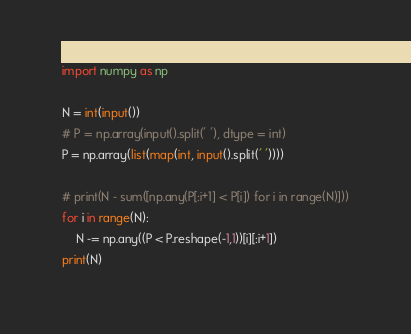<code> <loc_0><loc_0><loc_500><loc_500><_Python_>import numpy as np

N = int(input())
# P = np.array(input().split(' '), dtype = int)
P = np.array(list(map(int, input().split(' '))))

# print(N - sum([np.any(P[:i+1] < P[i]) for i in range(N)]))
for i in range(N):
    N -= np.any((P < P.reshape(-1,1))[i][:i+1])
print(N)
</code> 